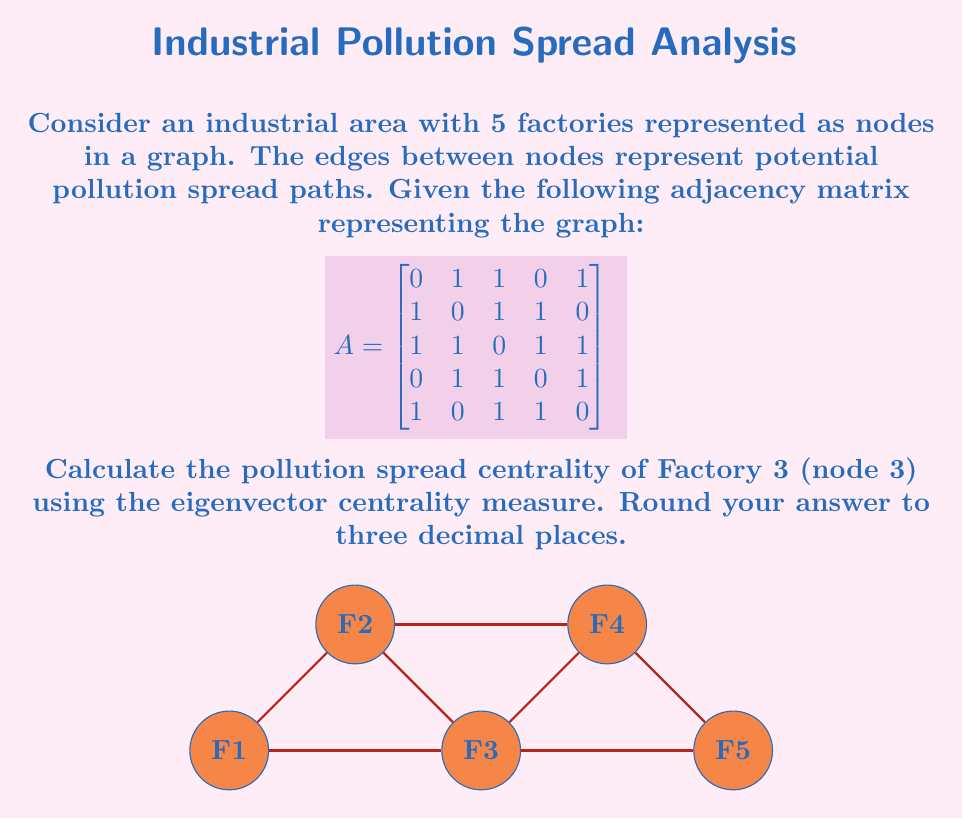Give your solution to this math problem. To calculate the eigenvector centrality of Factory 3, we need to follow these steps:

1) First, we need to find the principal eigenvector of the adjacency matrix A. This is the eigenvector corresponding to the largest eigenvalue.

2) We can use the power iteration method to approximate this eigenvector:
   
   a) Start with an initial vector $x_0 = [1, 1, 1, 1, 1]^T$
   b) Repeatedly multiply by A and normalize:
      $x_{k+1} = \frac{Ax_k}{||Ax_k||}$

3) After several iterations, we get the approximate principal eigenvector:

   $$x \approx [0.4472, 0.4472, 0.5477, 0.4472, 0.3162]^T$$

4) The eigenvector centrality of each node is its corresponding value in this vector.

5) For Factory 3 (node 3), the centrality is the third component of this vector: 0.5477

6) Rounding to three decimal places gives 0.548.

This higher centrality for Factory 3 indicates that it has a more significant role in potential pollution spread within the network, which aligns with its central position in the graph and its connections to all other nodes.
Answer: 0.548 